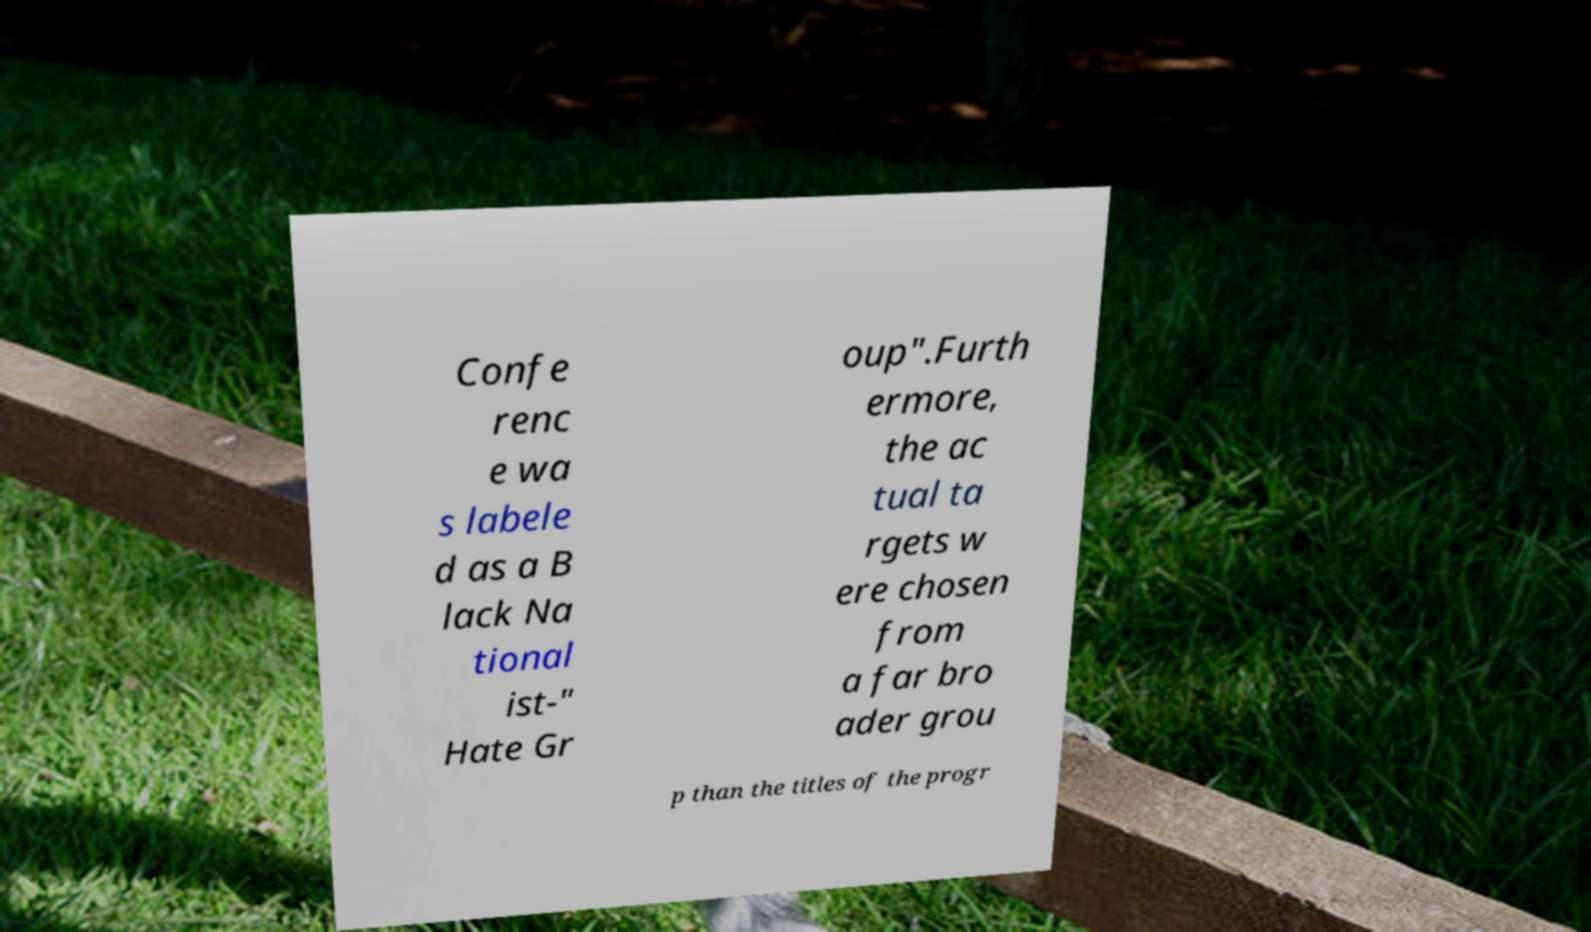Can you read and provide the text displayed in the image?This photo seems to have some interesting text. Can you extract and type it out for me? Confe renc e wa s labele d as a B lack Na tional ist-" Hate Gr oup".Furth ermore, the ac tual ta rgets w ere chosen from a far bro ader grou p than the titles of the progr 